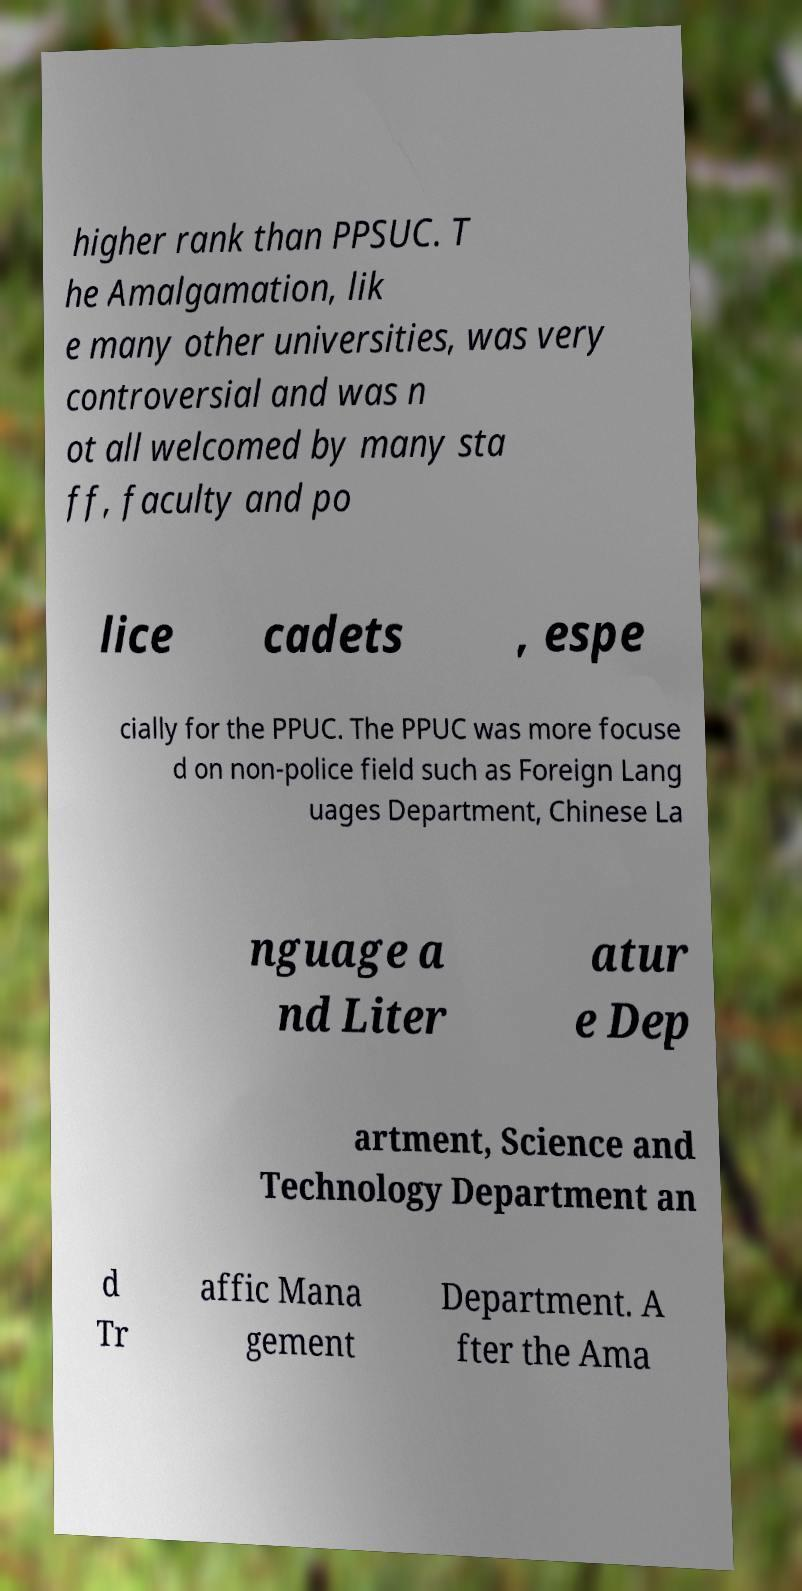Please identify and transcribe the text found in this image. higher rank than PPSUC. T he Amalgamation, lik e many other universities, was very controversial and was n ot all welcomed by many sta ff, faculty and po lice cadets , espe cially for the PPUC. The PPUC was more focuse d on non-police field such as Foreign Lang uages Department, Chinese La nguage a nd Liter atur e Dep artment, Science and Technology Department an d Tr affic Mana gement Department. A fter the Ama 